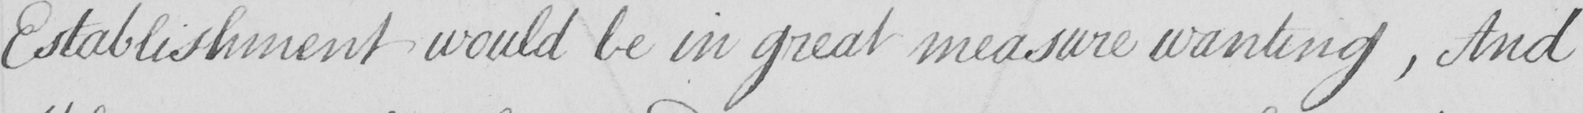Please provide the text content of this handwritten line. Establishment would be in great measure wanting , And 